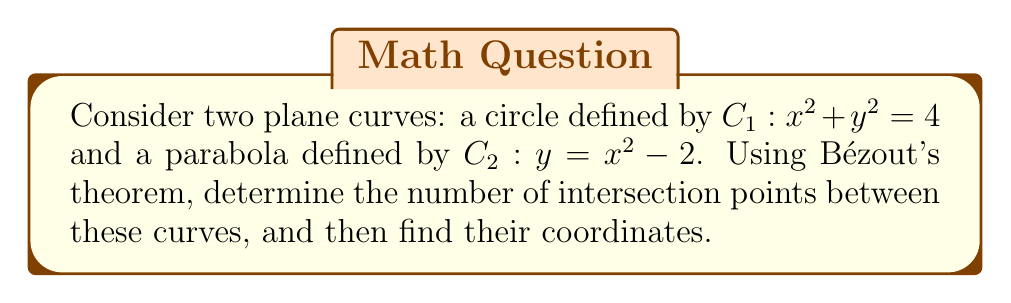Teach me how to tackle this problem. Let's approach this step-by-step:

1) Bézout's theorem states that the number of intersection points between two plane curves is equal to the product of their degrees, counting multiplicities.

2) The degree of $C_1$ (circle) is 2, and the degree of $C_2$ (parabola) is also 2.

3) By Bézout's theorem, we expect $2 \times 2 = 4$ intersection points, counting multiplicities.

4) To find the intersection points, we need to solve the system of equations:
   $$\begin{cases}
   x^2 + y^2 = 4 \\
   y = x^2 - 2
   \end{cases}$$

5) Substitute the second equation into the first:
   $$x^2 + (x^2 - 2)^2 = 4$$

6) Expand:
   $$x^2 + x^4 - 4x^2 + 4 = 4$$

7) Simplify:
   $$x^4 - 3x^2 = 0$$

8) Factor:
   $$x^2(x^2 - 3) = 0$$

9) Solve:
   $$x = 0 \text{ or } x = \pm\sqrt{3}$$

10) For $x = 0$:
    $y = 0^2 - 2 = -2$
    So, $(0, -2)$ is an intersection point.

11) For $x = \sqrt{3}$:
    $y = (\sqrt{3})^2 - 2 = 1$
    So, $(\sqrt{3}, 1)$ is an intersection point.

12) For $x = -\sqrt{3}$:
    $y = (-\sqrt{3})^2 - 2 = 1$
    So, $(-\sqrt{3}, 1)$ is an intersection point.

13) We have found all 4 intersection points predicted by Bézout's theorem: $(0, -2)$ with multiplicity 2 (tangent point), $(\sqrt{3}, 1)$, and $(-\sqrt{3}, 1)$.
Answer: 4 intersection points: $(0, -2)$ (double point), $(\sqrt{3}, 1)$, $(-\sqrt{3}, 1)$ 